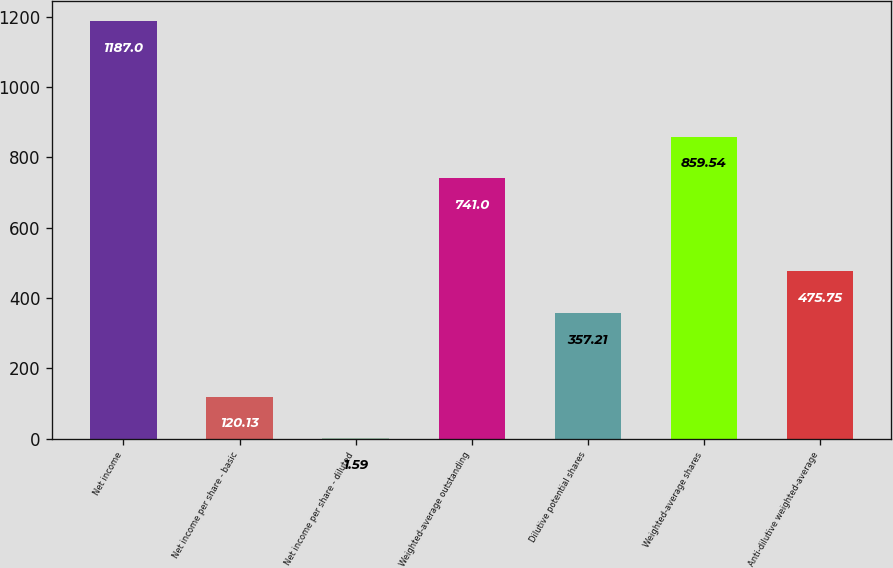Convert chart to OTSL. <chart><loc_0><loc_0><loc_500><loc_500><bar_chart><fcel>Net income<fcel>Net income per share - basic<fcel>Net income per share - diluted<fcel>Weighted-average outstanding<fcel>Dilutive potential shares<fcel>Weighted-average shares<fcel>Anti-dilutive weighted-average<nl><fcel>1187<fcel>120.13<fcel>1.59<fcel>741<fcel>357.21<fcel>859.54<fcel>475.75<nl></chart> 